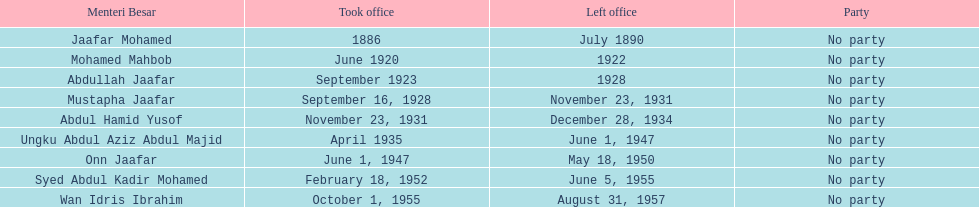What is the number of menteri besars that there have been during the pre-independence period? 9. 